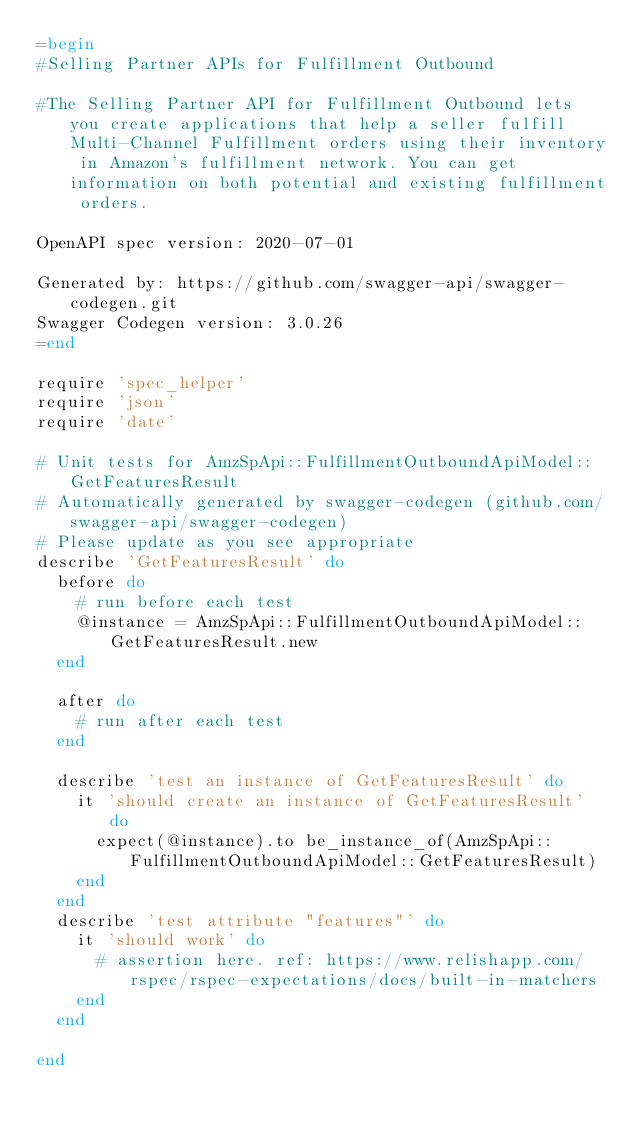<code> <loc_0><loc_0><loc_500><loc_500><_Ruby_>=begin
#Selling Partner APIs for Fulfillment Outbound

#The Selling Partner API for Fulfillment Outbound lets you create applications that help a seller fulfill Multi-Channel Fulfillment orders using their inventory in Amazon's fulfillment network. You can get information on both potential and existing fulfillment orders.

OpenAPI spec version: 2020-07-01

Generated by: https://github.com/swagger-api/swagger-codegen.git
Swagger Codegen version: 3.0.26
=end

require 'spec_helper'
require 'json'
require 'date'

# Unit tests for AmzSpApi::FulfillmentOutboundApiModel::GetFeaturesResult
# Automatically generated by swagger-codegen (github.com/swagger-api/swagger-codegen)
# Please update as you see appropriate
describe 'GetFeaturesResult' do
  before do
    # run before each test
    @instance = AmzSpApi::FulfillmentOutboundApiModel::GetFeaturesResult.new
  end

  after do
    # run after each test
  end

  describe 'test an instance of GetFeaturesResult' do
    it 'should create an instance of GetFeaturesResult' do
      expect(@instance).to be_instance_of(AmzSpApi::FulfillmentOutboundApiModel::GetFeaturesResult)
    end
  end
  describe 'test attribute "features"' do
    it 'should work' do
      # assertion here. ref: https://www.relishapp.com/rspec/rspec-expectations/docs/built-in-matchers
    end
  end

end
</code> 